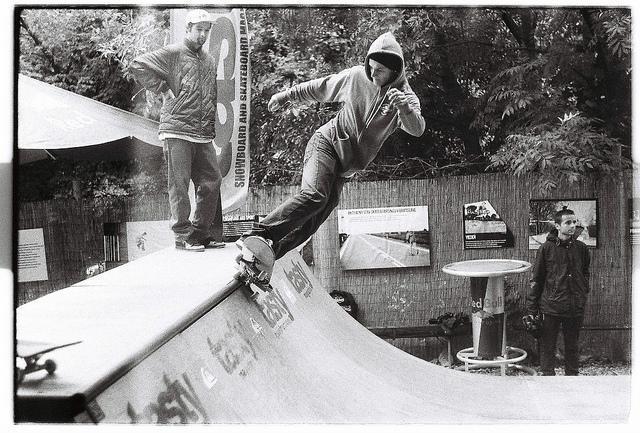How many people are visible?
Give a very brief answer. 3. How many bunk beds are in the photo?
Give a very brief answer. 0. 